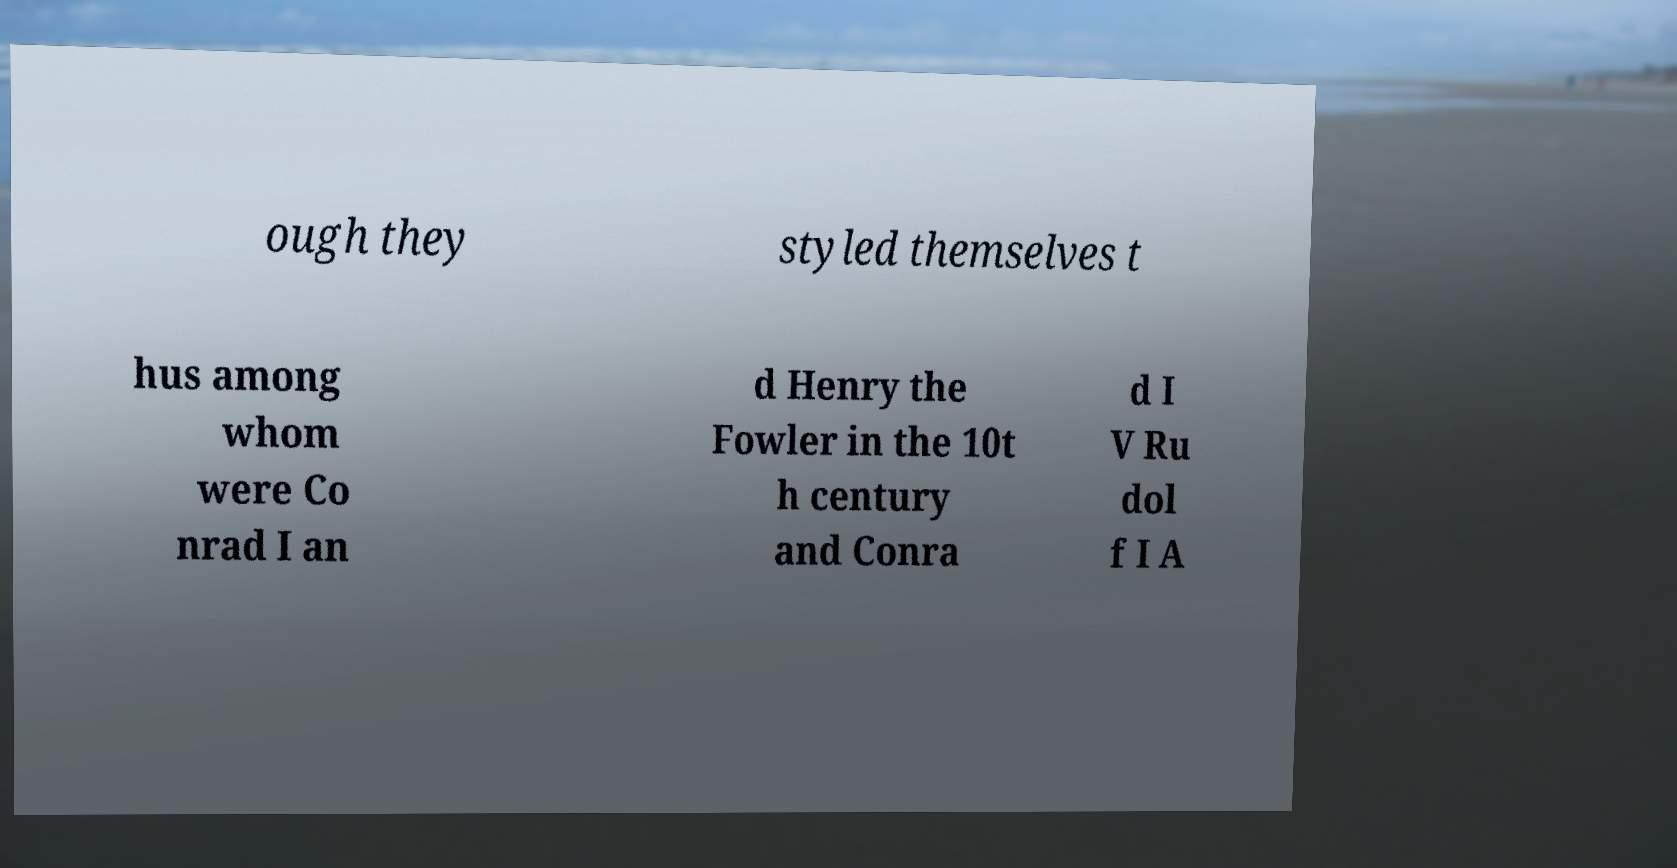Can you accurately transcribe the text from the provided image for me? ough they styled themselves t hus among whom were Co nrad I an d Henry the Fowler in the 10t h century and Conra d I V Ru dol f I A 